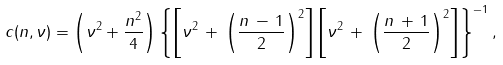<formula> <loc_0><loc_0><loc_500><loc_500>c ( n , \nu ) = \left ( \nu ^ { 2 } + \frac { n ^ { 2 } } { 4 } \right ) \left \{ \left [ \nu ^ { 2 } \, + \, \left ( \frac { n \, - \, 1 } 2 \right ) ^ { 2 } \right ] \left [ \nu ^ { 2 } \, + \, \left ( \frac { n \, + \, 1 } 2 \right ) ^ { 2 } \right ] \right \} ^ { - 1 } ,</formula> 